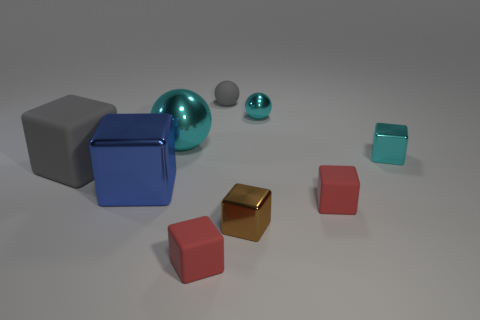How many other objects are there of the same shape as the big rubber object? Apart from the largest rubber object, which appears to be a sphere, there are two smaller spheres. Therefore, there are two objects of the same shape as the big rubber sphere. 